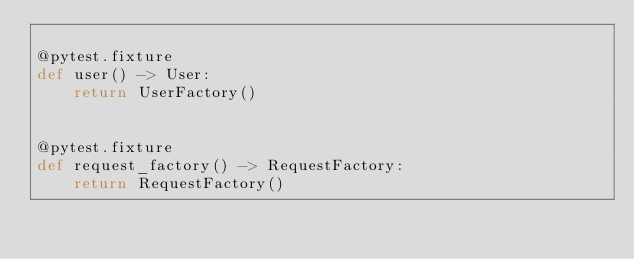Convert code to text. <code><loc_0><loc_0><loc_500><loc_500><_Python_>
@pytest.fixture
def user() -> User:
    return UserFactory()


@pytest.fixture
def request_factory() -> RequestFactory:
    return RequestFactory()
</code> 